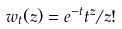Convert formula to latex. <formula><loc_0><loc_0><loc_500><loc_500>w _ { t } ( z ) = e ^ { - t } t ^ { z } / z !</formula> 